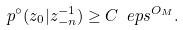<formula> <loc_0><loc_0><loc_500><loc_500>p ^ { \circ } ( z _ { 0 } | z _ { - n } ^ { - 1 } ) \geq C \ e p s ^ { O _ { M } } .</formula> 